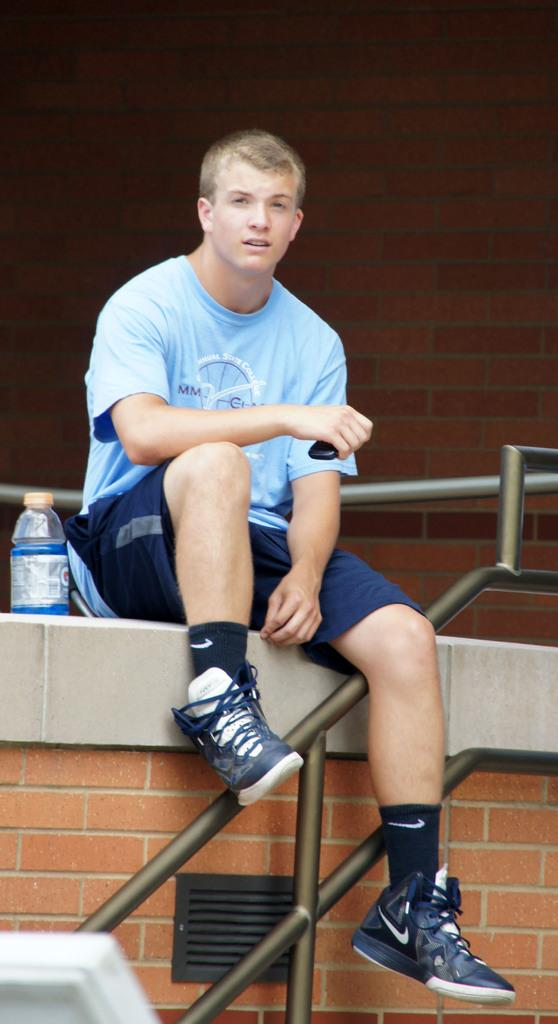What is the man in the image doing? The man is sitting in the image. Can you describe anything behind the man? There is a water bottle behind the man. What type of mind-reading machine is the man using in the image? There is no mind-reading machine present in the image. 